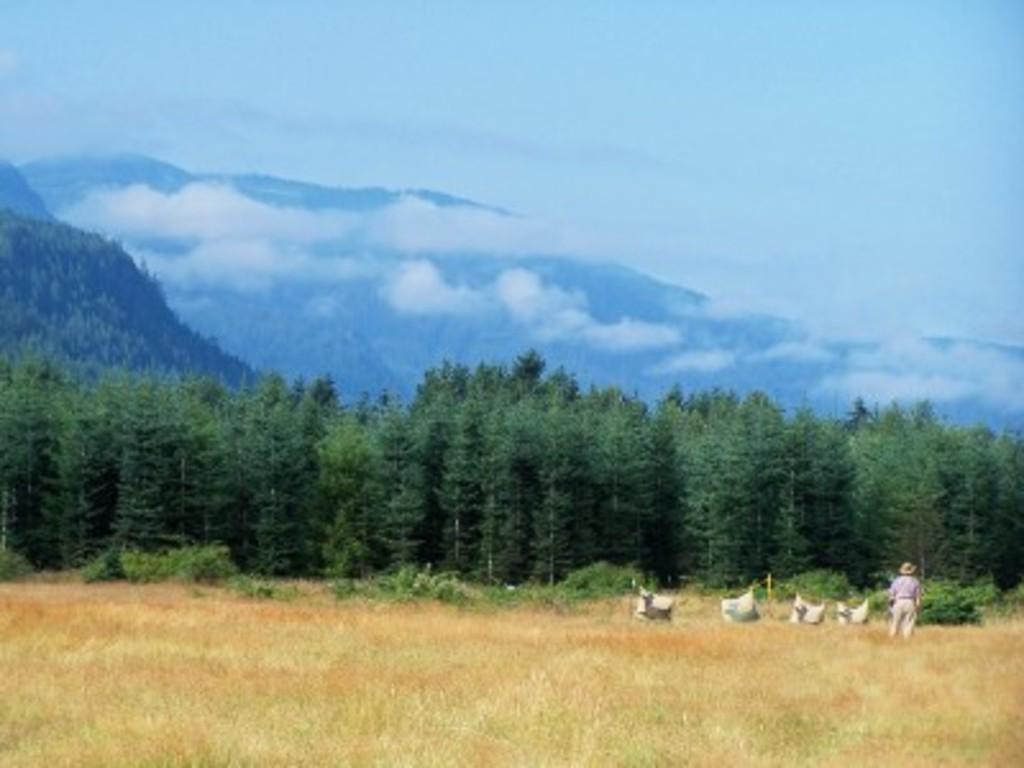How would you summarize this image in a sentence or two? This picture is clicked outside the city. In the foreground we can see the grass. In the center we can see the plants and trees and there is a person standing on the ground and there are some objects seems to be placed on the ground. In the background we can see the sky which is full of clouds and there are some objects seems to be the hills. 